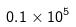Convert formula to latex. <formula><loc_0><loc_0><loc_500><loc_500>0 . 1 \times 1 0 ^ { 5 }</formula> 